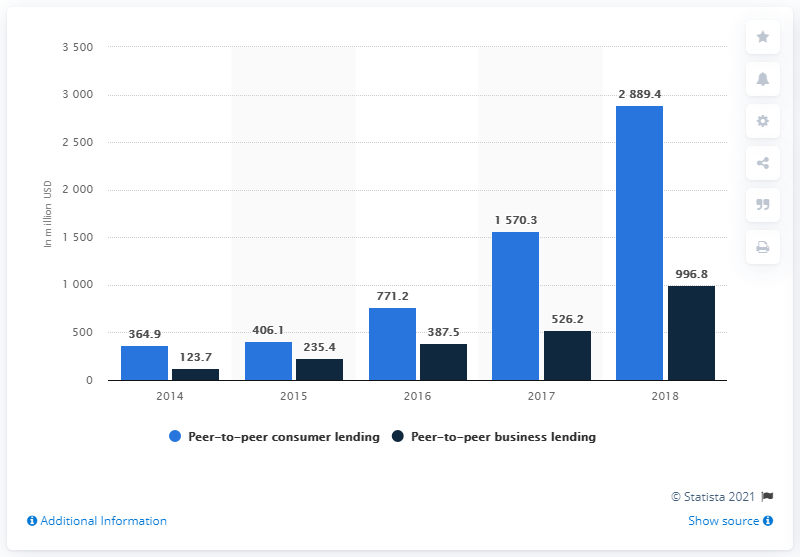List a handful of essential elements in this visual. The total value of P2P consumer lending in 2018 was 2889.4. 